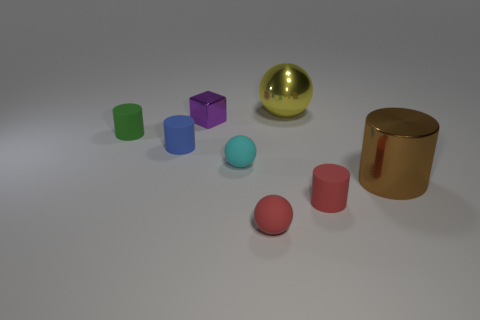Subtract 1 cylinders. How many cylinders are left? 3 Subtract all yellow balls. Subtract all blue cylinders. How many balls are left? 2 Add 1 big blue spheres. How many objects exist? 9 Subtract all balls. How many objects are left? 5 Subtract all tiny blue rubber things. Subtract all small blue rubber things. How many objects are left? 6 Add 3 small purple blocks. How many small purple blocks are left? 4 Add 5 tiny blue rubber objects. How many tiny blue rubber objects exist? 6 Subtract 0 red blocks. How many objects are left? 8 